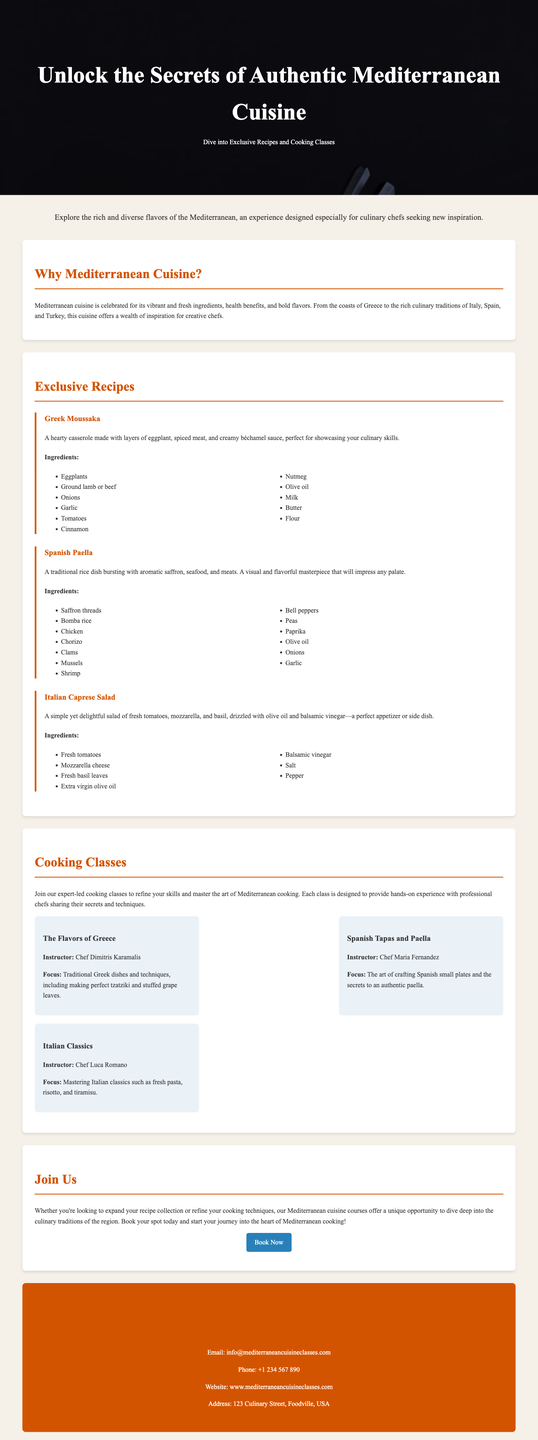What is the title of the advertisement? The title of the advertisement is prominently displayed in large text at the top of the document.
Answer: Unlock the Secrets of Authentic Mediterranean Cuisine What is a highlighted feature of Mediterranean cuisine? This feature is discussed in the section titled "Why Mediterranean Cuisine?" which emphasizes its vibrant and fresh ingredients.
Answer: Vibrant and fresh ingredients Who is the instructor for the class "The Flavors of Greece"? This information can be found in the cooking classes section, detailing the instructors for each class.
Answer: Chef Dimitris Karamalis How many exclusive recipes are mentioned? The document lists a specific number of recipes in the "Exclusive Recipes" section.
Answer: Three What type of salad is featured as an exclusive recipe? This dish's name is mentioned in the "Exclusive Recipes" section with a description.
Answer: Caprese Salad What is a major focus of the "Spanish Tapas and Paella" class? The focus of this cooking class is specified directly after the instructor's name in the document.
Answer: Crafting Spanish small plates Where can you find the contact email for the classes? This contact information is located in the last section of the document.
Answer: info@mediterraneancuisineclasses.com What is the color of the button to book a class? This information can be observed by describing the button's design and color.
Answer: Blue 